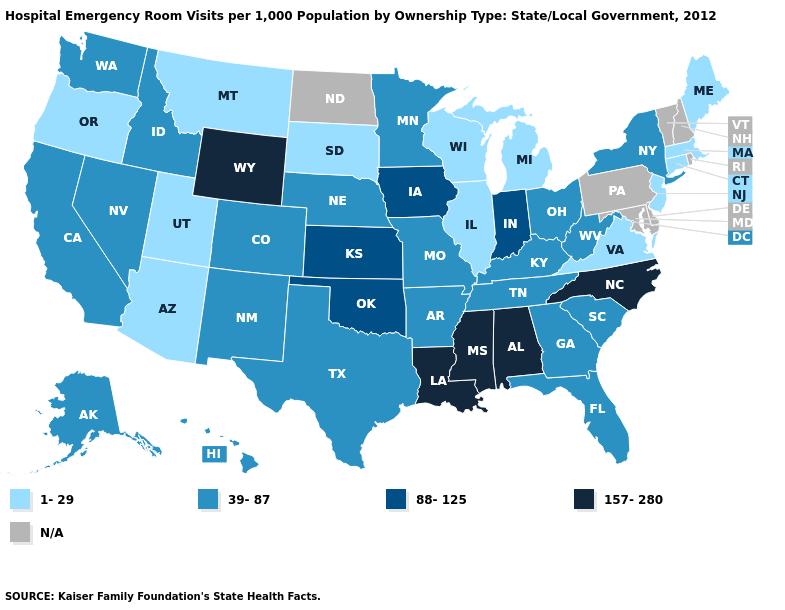What is the value of Louisiana?
Answer briefly. 157-280. What is the highest value in states that border Connecticut?
Be succinct. 39-87. What is the value of Nevada?
Answer briefly. 39-87. Name the states that have a value in the range 1-29?
Keep it brief. Arizona, Connecticut, Illinois, Maine, Massachusetts, Michigan, Montana, New Jersey, Oregon, South Dakota, Utah, Virginia, Wisconsin. What is the lowest value in the USA?
Quick response, please. 1-29. Name the states that have a value in the range 157-280?
Short answer required. Alabama, Louisiana, Mississippi, North Carolina, Wyoming. Name the states that have a value in the range 157-280?
Quick response, please. Alabama, Louisiana, Mississippi, North Carolina, Wyoming. Does Wyoming have the highest value in the USA?
Keep it brief. Yes. Name the states that have a value in the range 88-125?
Be succinct. Indiana, Iowa, Kansas, Oklahoma. Name the states that have a value in the range 39-87?
Give a very brief answer. Alaska, Arkansas, California, Colorado, Florida, Georgia, Hawaii, Idaho, Kentucky, Minnesota, Missouri, Nebraska, Nevada, New Mexico, New York, Ohio, South Carolina, Tennessee, Texas, Washington, West Virginia. Which states have the highest value in the USA?
Quick response, please. Alabama, Louisiana, Mississippi, North Carolina, Wyoming. Does South Carolina have the highest value in the USA?
Quick response, please. No. What is the value of Florida?
Short answer required. 39-87. Is the legend a continuous bar?
Be succinct. No. Name the states that have a value in the range 1-29?
Short answer required. Arizona, Connecticut, Illinois, Maine, Massachusetts, Michigan, Montana, New Jersey, Oregon, South Dakota, Utah, Virginia, Wisconsin. 